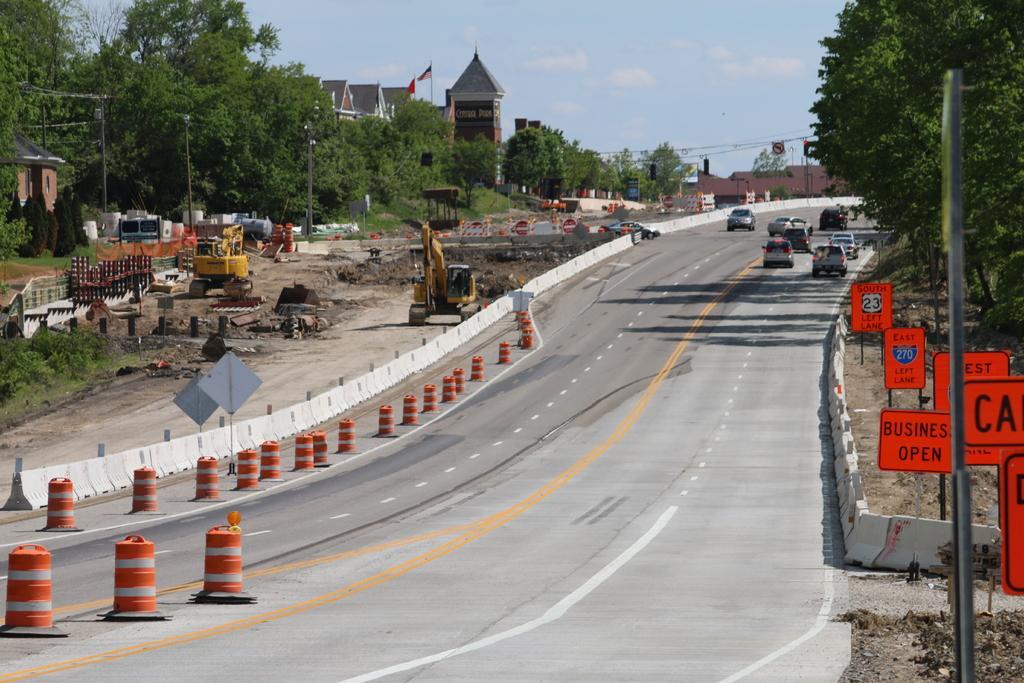Could you give a brief overview of what you see in this image? In this image we can see buildings, trees, electric poles, electric cables, sign boards, barrier poles, excavator, bulldozer, motor vehicles on the road and sky with clouds. 